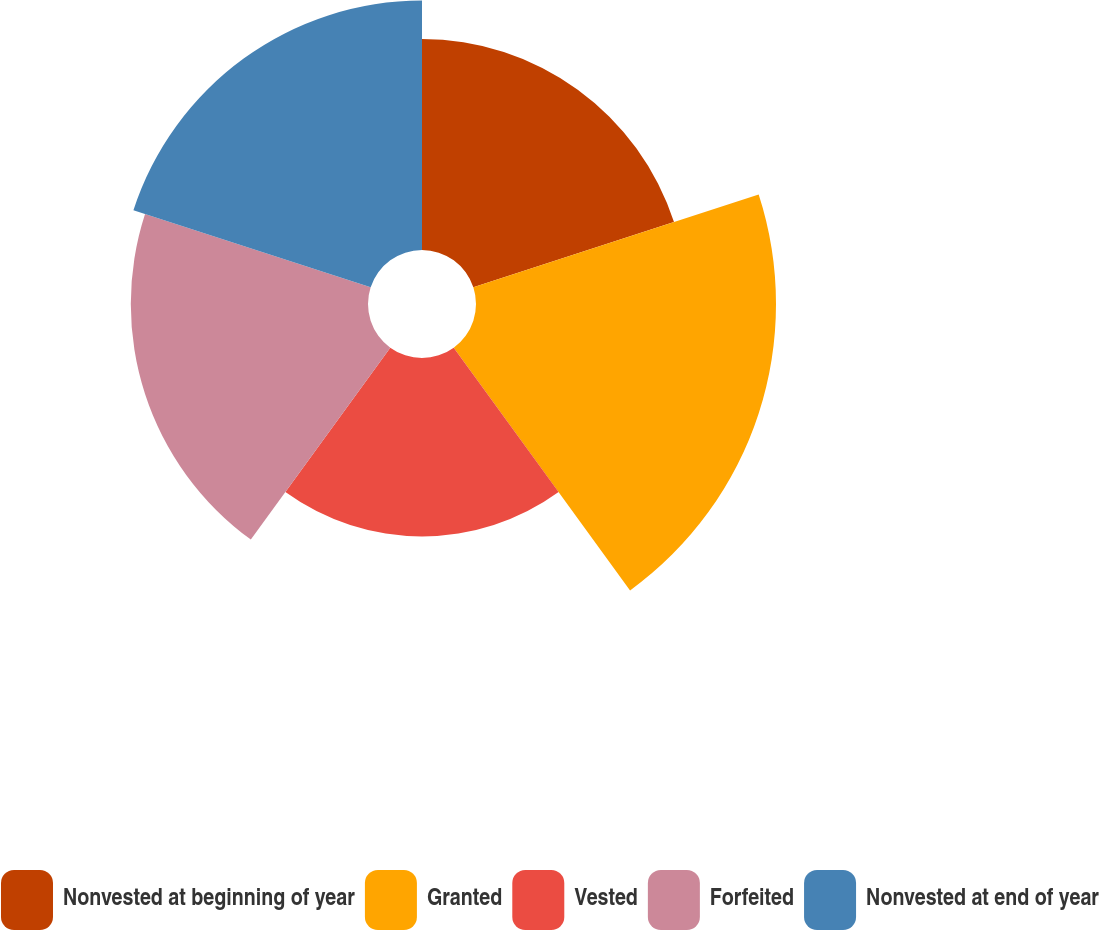<chart> <loc_0><loc_0><loc_500><loc_500><pie_chart><fcel>Nonvested at beginning of year<fcel>Granted<fcel>Vested<fcel>Forfeited<fcel>Nonvested at end of year<nl><fcel>17.94%<fcel>25.51%<fcel>15.17%<fcel>20.17%<fcel>21.21%<nl></chart> 